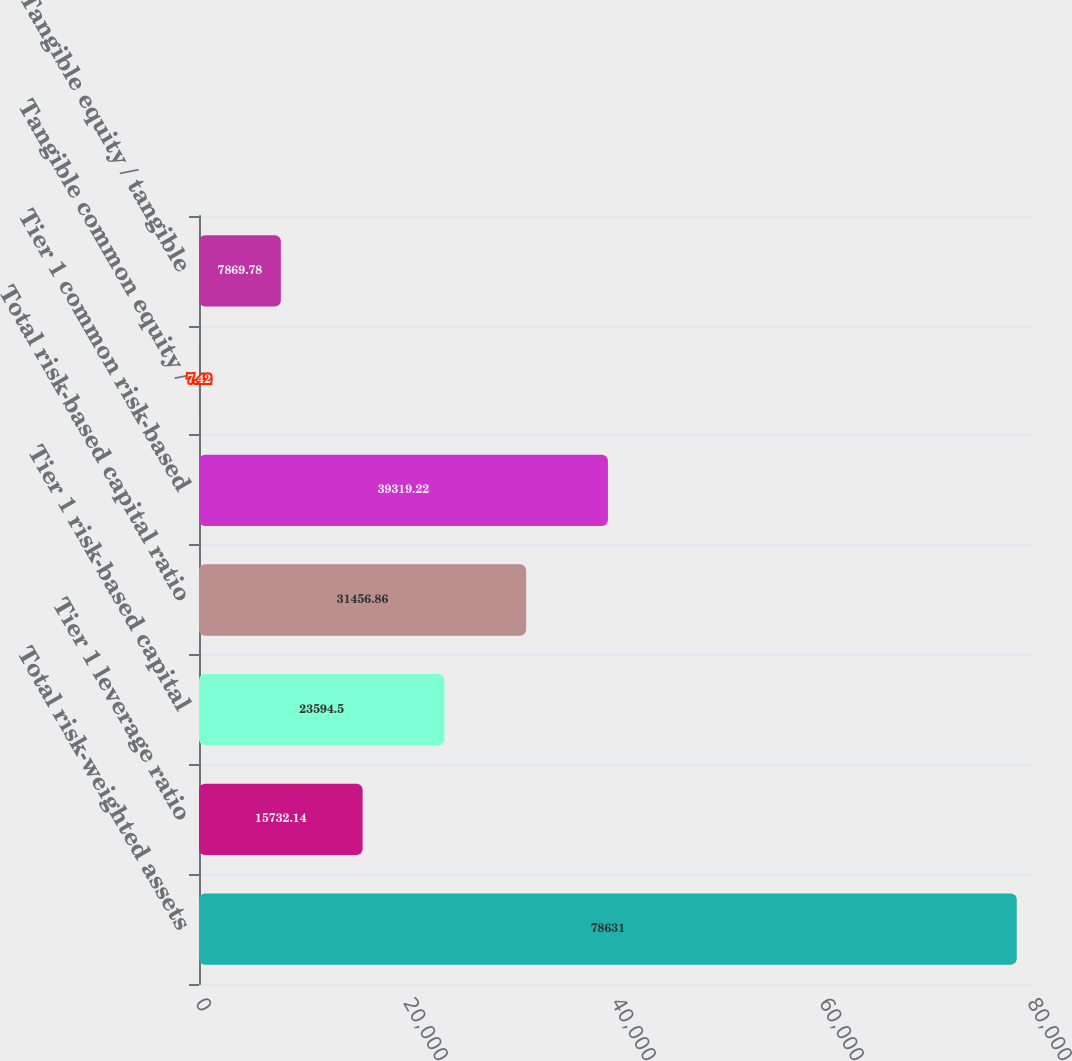<chart> <loc_0><loc_0><loc_500><loc_500><bar_chart><fcel>Total risk-weighted assets<fcel>Tier 1 leverage ratio<fcel>Tier 1 risk-based capital<fcel>Total risk-based capital ratio<fcel>Tier 1 common risk-based<fcel>Tangible common equity /<fcel>Tangible equity / tangible<nl><fcel>78631<fcel>15732.1<fcel>23594.5<fcel>31456.9<fcel>39319.2<fcel>7.42<fcel>7869.78<nl></chart> 